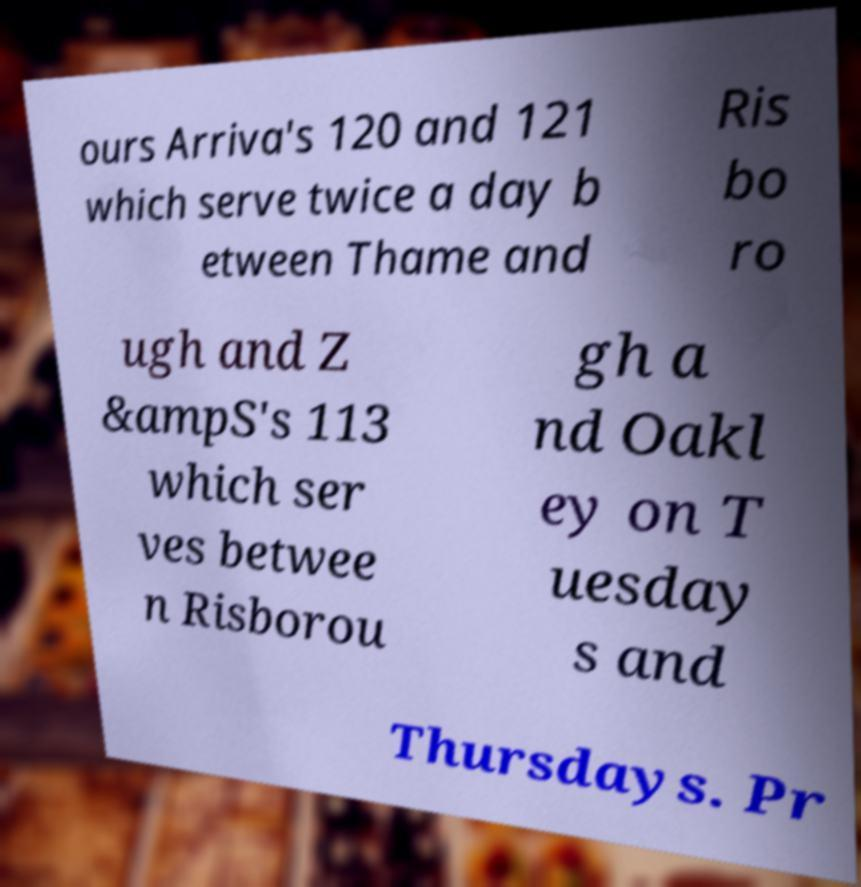There's text embedded in this image that I need extracted. Can you transcribe it verbatim? ours Arriva's 120 and 121 which serve twice a day b etween Thame and Ris bo ro ugh and Z &ampS's 113 which ser ves betwee n Risborou gh a nd Oakl ey on T uesday s and Thursdays. Pr 